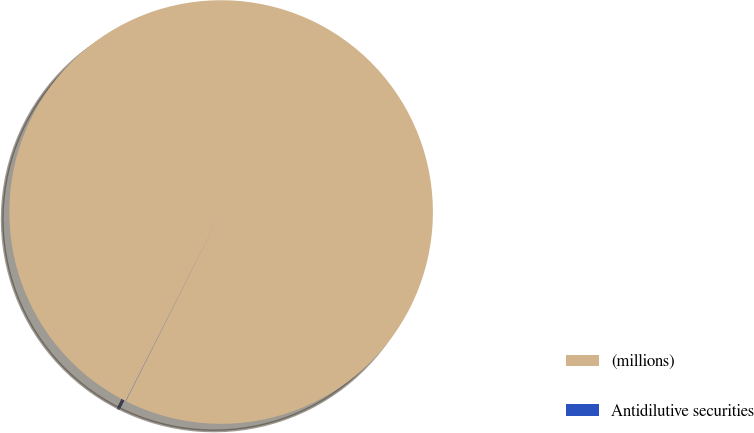Convert chart to OTSL. <chart><loc_0><loc_0><loc_500><loc_500><pie_chart><fcel>(millions)<fcel>Antidilutive securities<nl><fcel>99.98%<fcel>0.02%<nl></chart> 